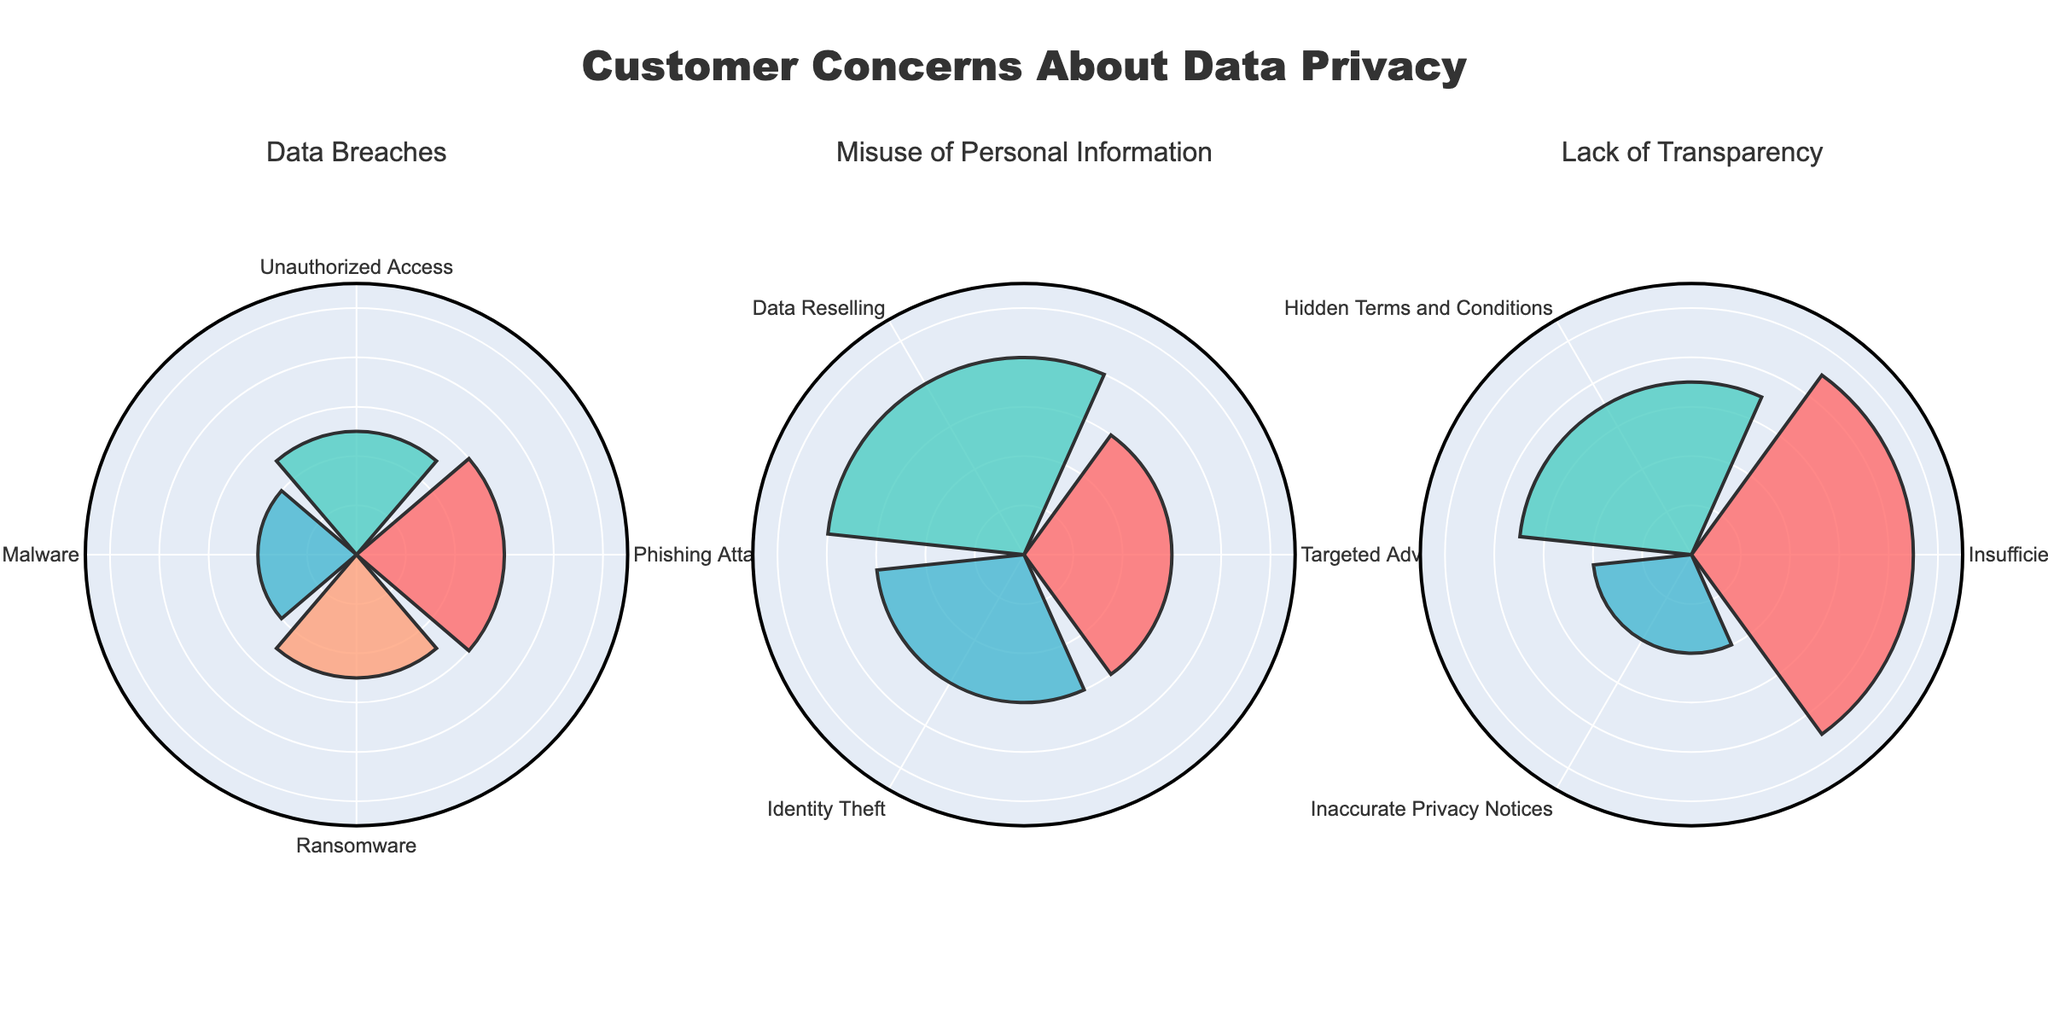What is the title of the figure? The title is located at the top center of the figure and is usually one of the most noticeable elements. The title helps viewers understand the main topic or focus of the visualization.
Answer: Customer Concerns About Data Privacy How many categories of customer concerns are displayed in the figure? The categories of customer concerns are indicated by the subplot titles. Each subplot corresponds to a different category.
Answer: 3 Which category has the highest concern proportion for a single issue, and what is that proportion? By looking at the radial lengths in the subplots, the "Lack of Transparency" category has the highest single issue concern with 'Insufficient Privacy Policies' at 45.
Answer: Lack of Transparency, 45 What is the sum of proportions for concerns under "Data Breaches"? Sum the proportions for each concern within the "Data Breaches" category: 30 (Phishing Attacks) + 25 (Unauthorized Access) + 20 (Malware) + 25 (Ransomware) = 100.
Answer: 100 Which specific concern within "Misuse of Personal Information" has the highest proportion? By comparing the radial lengths of the concerns within the "Misuse of Personal Information" subplot, 'Data Reselling' has the highest proportion at 40.
Answer: Data Reselling How does the proportion of 'Identity Theft' in "Misuse of Personal Information" compare to 'Unauthorized Access' in "Data Breaches"? Compare the radial lengths for these concerns. 'Identity Theft' has a proportion of 30, while 'Unauthorized Access' has a proportion of 25.
Answer: Identity Theft is greater Calculate the average proportion of concerns under "Lack of Transparency". Add the proportions for the concerns under "Lack of Transparency": 45 + 35 + 20 = 100. Then divide by the number of concerns: 100 / 3 ≈ 33.33.
Answer: 33.33 Which category has the lowest combined proportion of concerns? Calculate the combined proportions for each category: "Data Breaches" is 100, "Misuse of Personal Information" is 100, and "Lack of Transparency" is 100. Since all are equal, there is no one category with the lowest.
Answer: All equal, 100 Is the proportion of 'Malware' in "Data Breaches" greater than the lowest concern in "Lack of Transparency"? The proportion for 'Malware' is 20, while the lowest concern in "Lack of Transparency" is 'Inaccurate Privacy Notices' at 20. Comparing these, they are equal in value.
Answer: Equal 